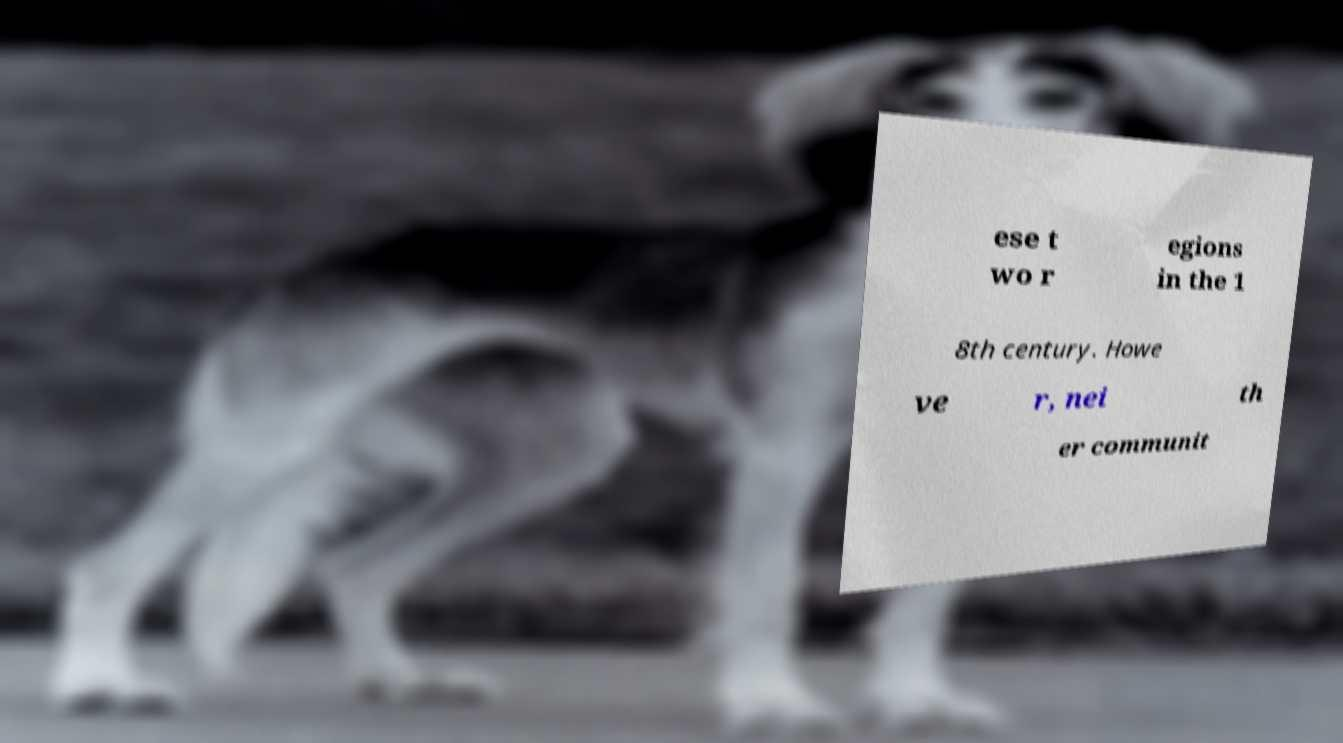Could you extract and type out the text from this image? ese t wo r egions in the 1 8th century. Howe ve r, nei th er communit 